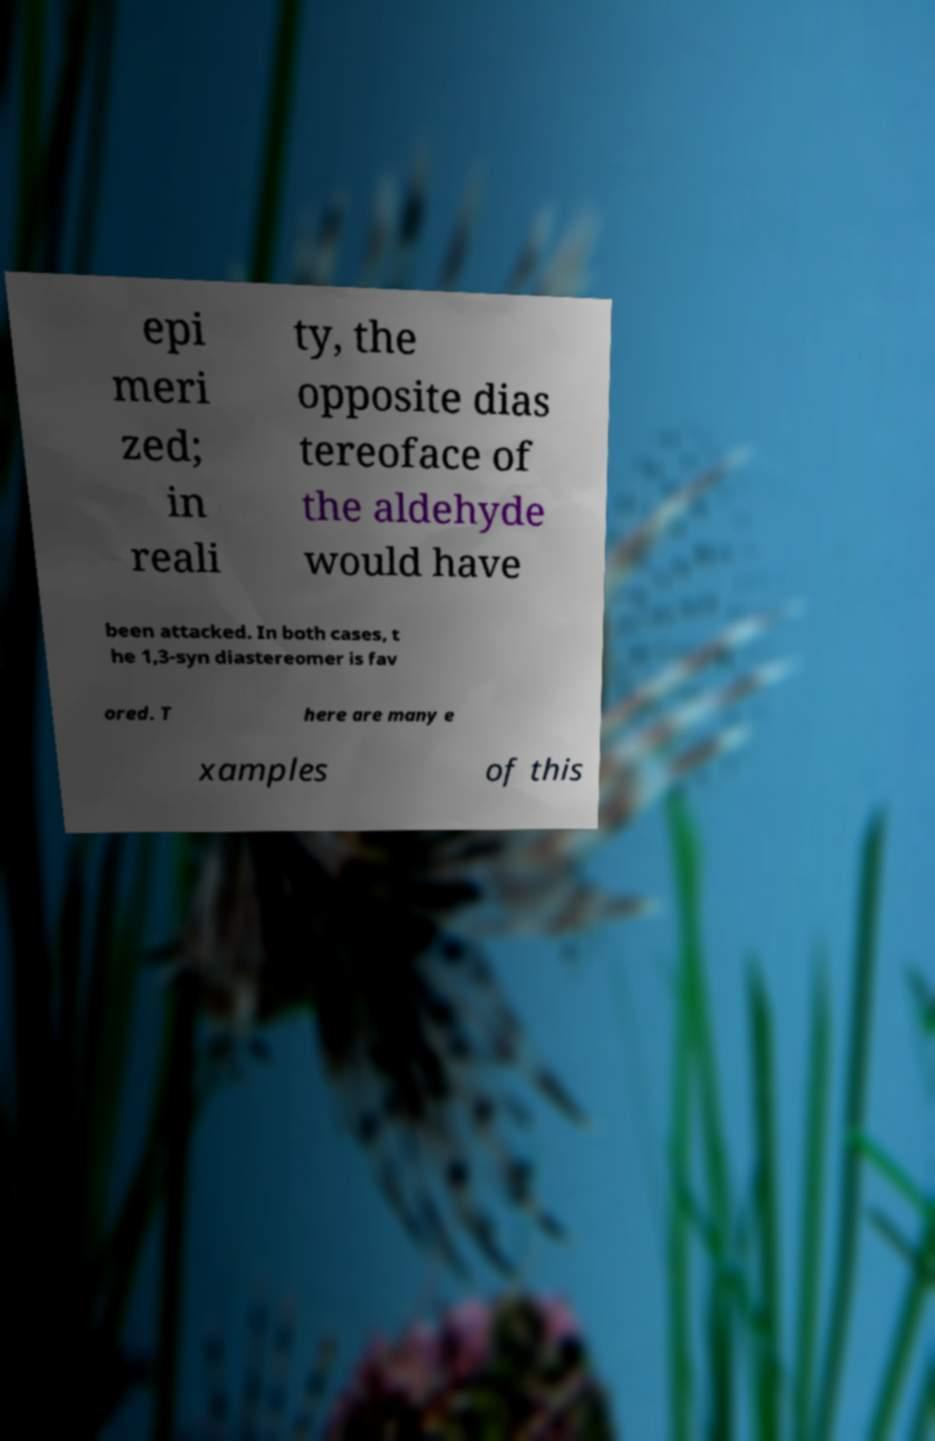There's text embedded in this image that I need extracted. Can you transcribe it verbatim? epi meri zed; in reali ty, the opposite dias tereoface of the aldehyde would have been attacked. In both cases, t he 1,3-syn diastereomer is fav ored. T here are many e xamples of this 